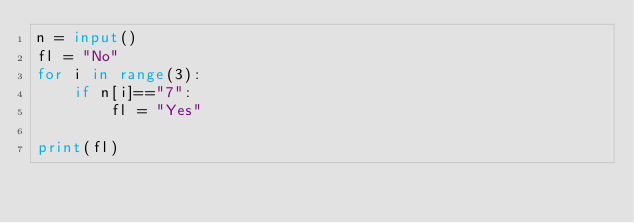Convert code to text. <code><loc_0><loc_0><loc_500><loc_500><_Python_>n = input()
fl = "No"
for i in range(3):
    if n[i]=="7":
        fl = "Yes"
        
print(fl)</code> 